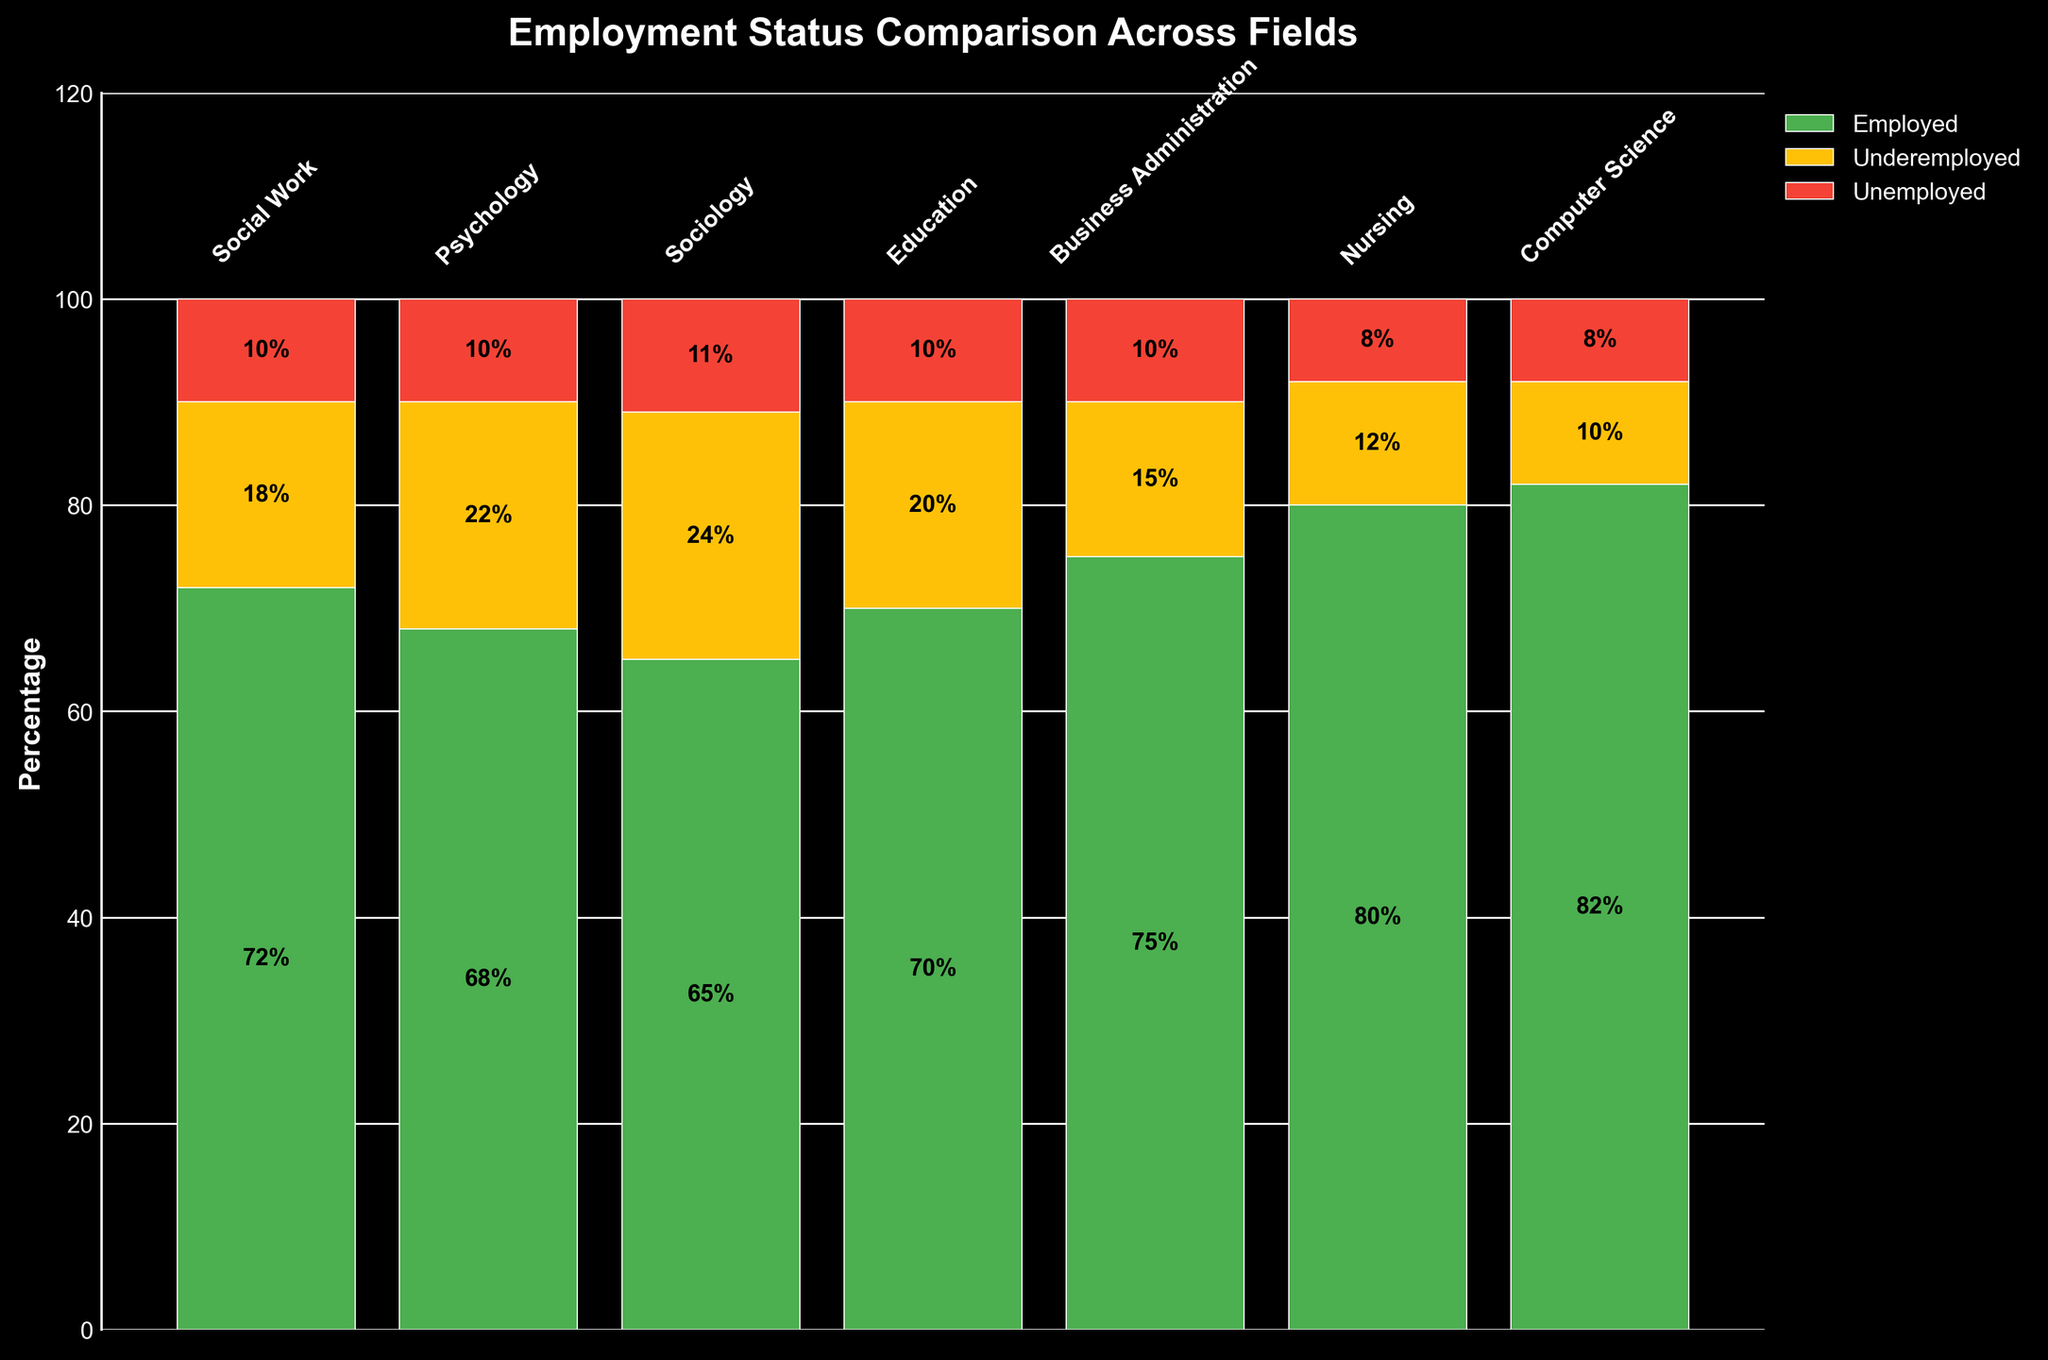How is the employment status distributed among social work graduates? The Social Work field has the following percentages: 72% Employed, 18% Underemployed, and 10% Unemployed. These percentages can be directly observed from the heights of the respective bars in the figure for Social Work.
Answer: 72% Employed, 18% Underemployed, 10% Unemployed Which field has the highest percentage of employed graduates? By comparing the heights of the 'Employed' sections of the bars for all fields in the plot, it is evident that the Computer Science field has the highest percentage, with 82% Employed.
Answer: Computer Science What is the total percentage of underemployed and unemployed graduates in Psychology? In the Psychology field, underemployment is at 22% and unemployment is at 10%. Adding these percentages gives the total: 22% + 10% = 32%.
Answer: 32% Which field has the lowest percentage of unemployed graduates? Observing the 'Unemployed' sections of the bars, Nursing and Computer Science both have the lowest percentage of unemployed graduates, each at 8%.
Answer: Nursing and Computer Science Compare the employment status of Sociology graduates to those in Business Administration. For Sociology, the percentages are 65% Employed, 24% Underemployed, and 11% Unemployed. For Business Administration, the values are 75% Employed, 15% Underemployed, and 10% Unemployed. Comparing these, Business Administration has a higher percentage of employed graduates (75% vs. 65%) and lower percentages of underemployed (15% vs. 24%) and unemployed graduates (10% vs. 11%).
Answer: Business Administration has higher employment and lower underemployment and unemployment What is the average percentage of employed graduates across all fields? The percentages of employed graduates in each field are: Social Work 72%, Psychology 68%, Sociology 65%, Education 70%, Business Administration 75%, Nursing 80%, and Computer Science 82%. Summing these values gives 72 + 68 + 65 + 70 + 75 + 80 + 82 = 512. There are 7 fields, so the average is 512/7 = approximately 73.14%.
Answer: Approximately 73.14% Which field has more underemployed graduates, Education or Social Work? From the bar heights for the 'Underemployed' sections, Education has 20% underemployed, and Social Work has 18%. Thus, Education has more underemployed graduates.
Answer: Education Determine the combined percentage of employed and underemployed graduates in the Nursing field. In Nursing, employed graduates make up 80%, and underemployed graduates constitute 12%. Their combined percentage is 80% + 12% = 92%.
Answer: 92% Which field has a higher proportion of underemployed graduates compared to employed graduates, Sociology or Psychology? Sociology has 24% underemployed and 65% employed, a ratio of 24/65 = 0.3692. Psychology has 22% underemployed and 68% employed, a ratio of 22/68 = 0.3235. Comparing these ratios, Sociology has a higher proportion of underemployed graduates relative to employed graduates as 0.3692 > 0.3235.
Answer: Sociology 